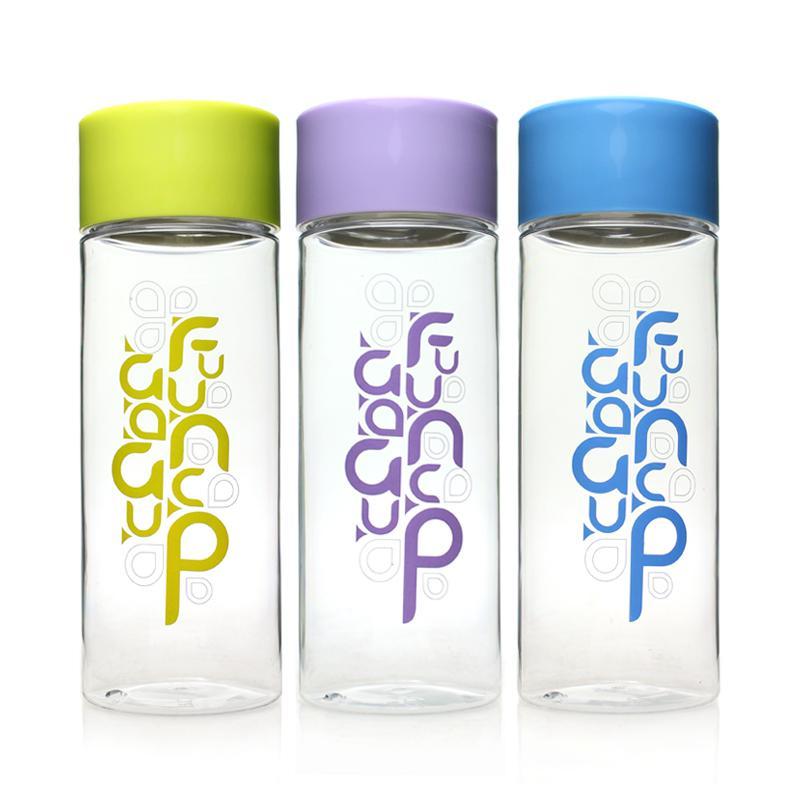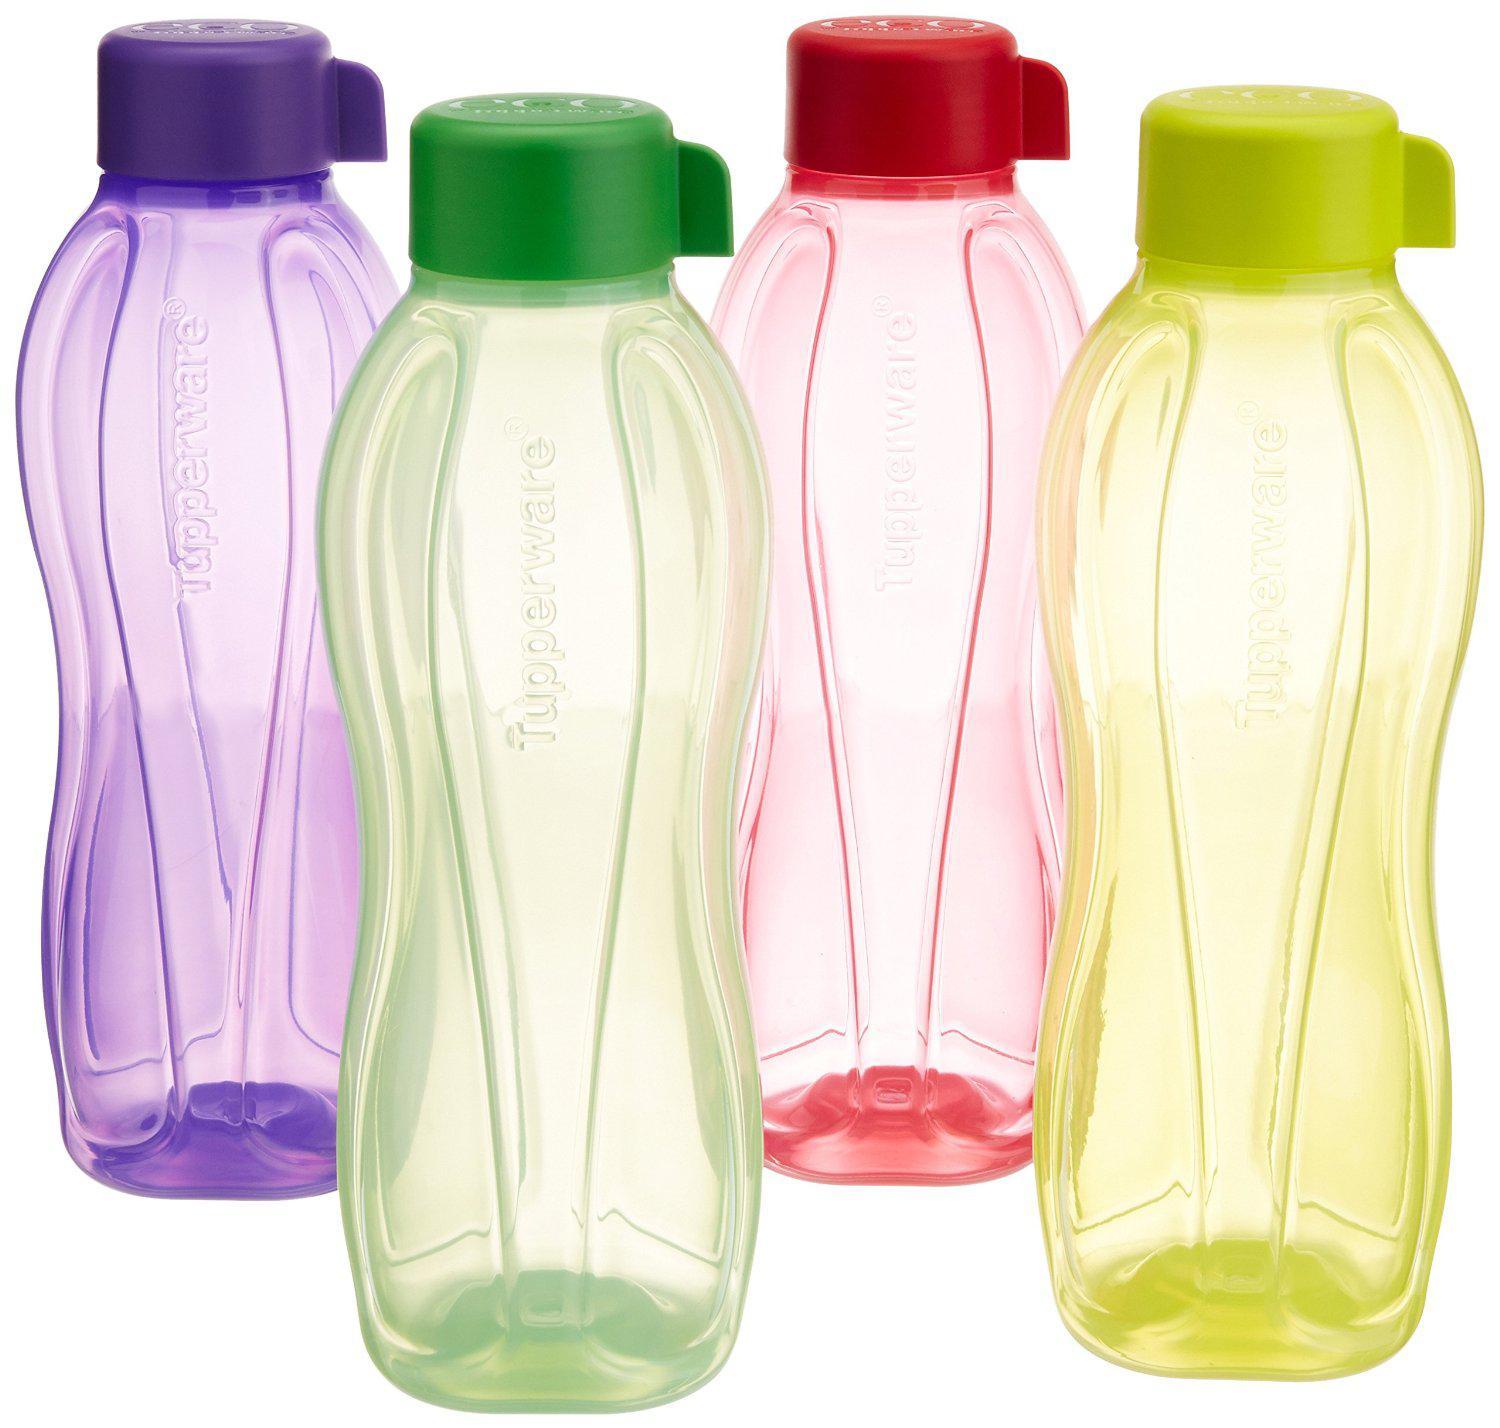The first image is the image on the left, the second image is the image on the right. Given the left and right images, does the statement "There is at least one bottle with fruit and water in it." hold true? Answer yes or no. No. The first image is the image on the left, the second image is the image on the right. For the images displayed, is the sentence "At least one container contains some slices of fruit in it." factually correct? Answer yes or no. No. 